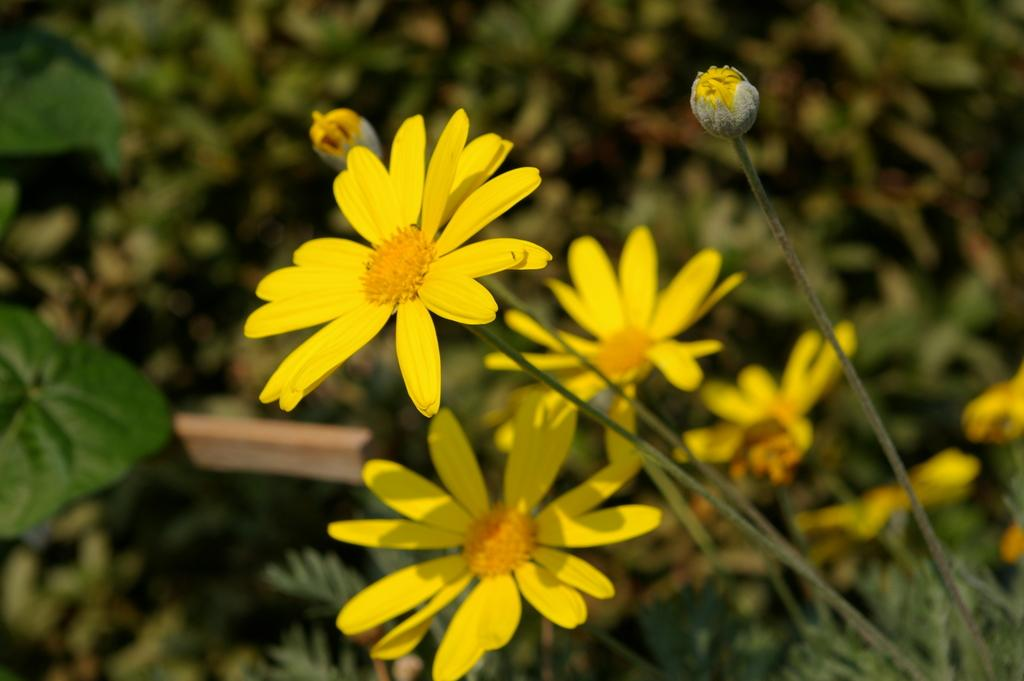What type of flowers can be seen in the foreground of the image? There are yellow flowers in the foreground of the image. What is the growth stage of the flowers in the foreground? There are two buds on the plant in the foreground. What can be seen in the background of the image? There are plants visible in the background of the image. What type of argument is taking place between the celery and the horn in the image? There is no celery or horn present in the image, so no such argument can be observed. 